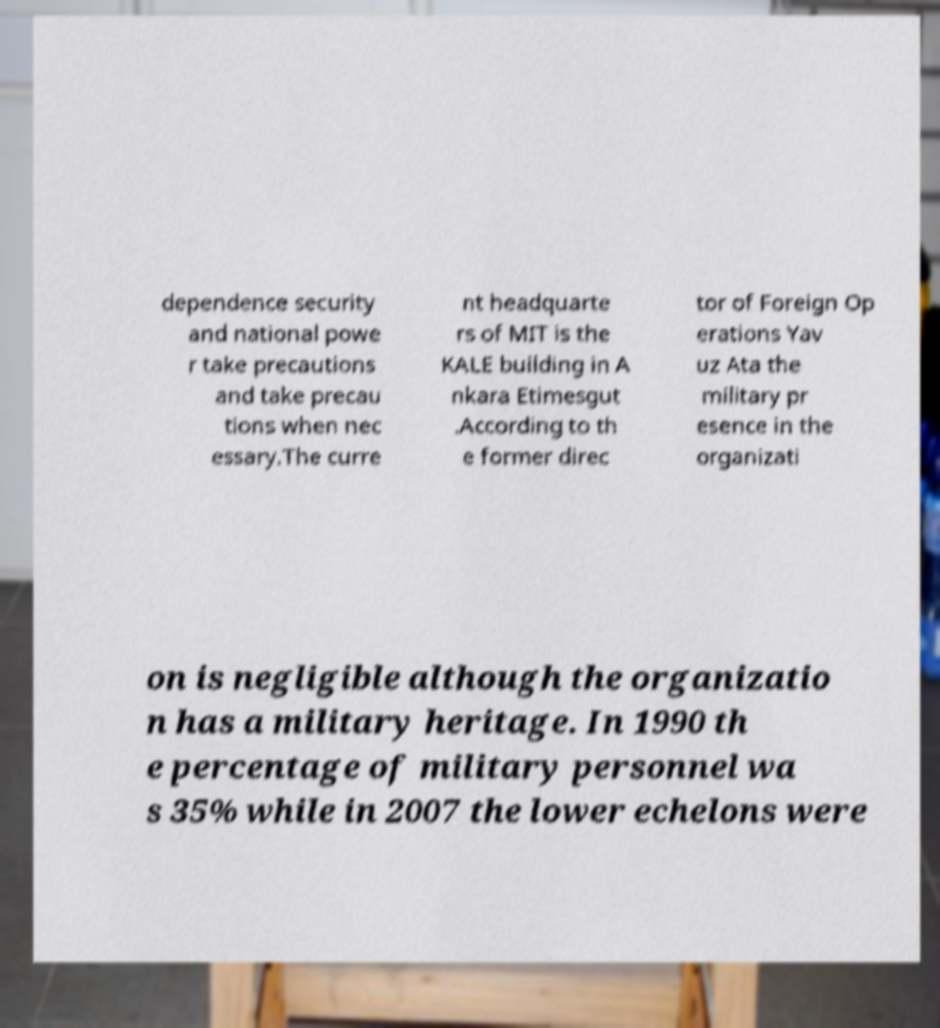For documentation purposes, I need the text within this image transcribed. Could you provide that? dependence security and national powe r take precautions and take precau tions when nec essary.The curre nt headquarte rs of MIT is the KALE building in A nkara Etimesgut .According to th e former direc tor of Foreign Op erations Yav uz Ata the military pr esence in the organizati on is negligible although the organizatio n has a military heritage. In 1990 th e percentage of military personnel wa s 35% while in 2007 the lower echelons were 